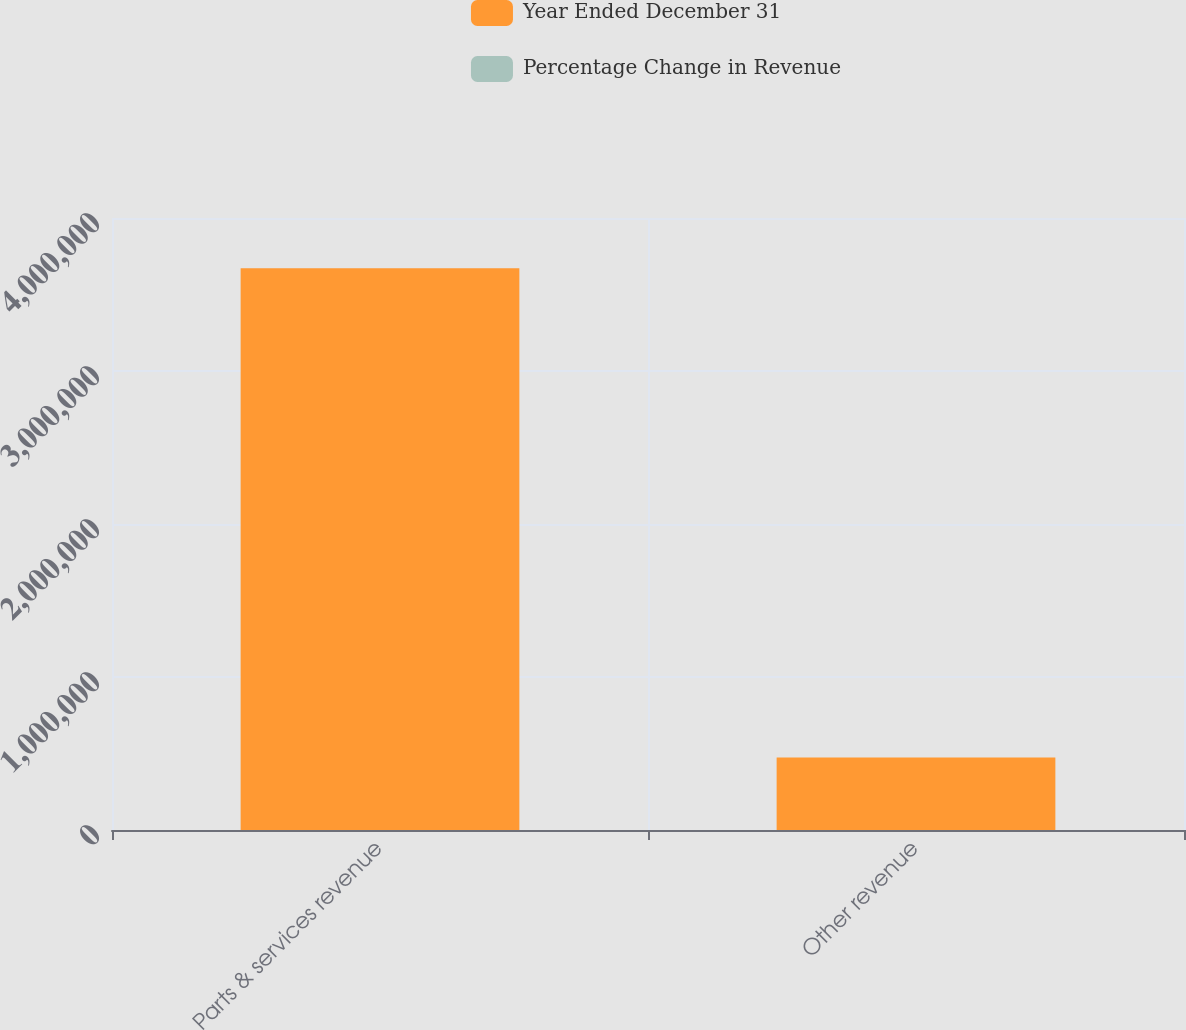Convert chart to OTSL. <chart><loc_0><loc_0><loc_500><loc_500><stacked_bar_chart><ecel><fcel>Parts & services revenue<fcel>Other revenue<nl><fcel>Year Ended December 31<fcel>3.6716e+06<fcel>474403<nl><fcel>Percentage Change in Revenue<fcel>5.6<fcel>28.8<nl></chart> 